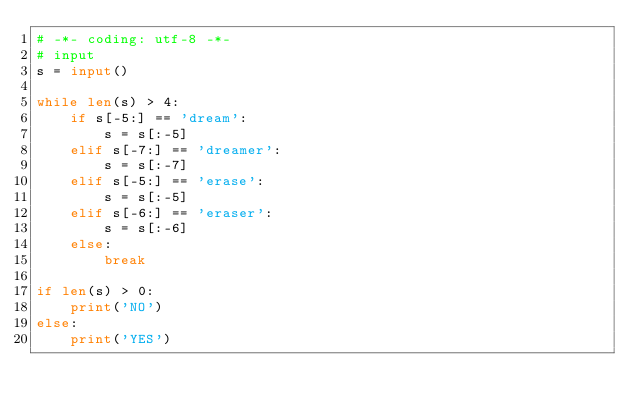Convert code to text. <code><loc_0><loc_0><loc_500><loc_500><_Python_># -*- coding: utf-8 -*-
# input
s = input()

while len(s) > 4:
    if s[-5:] == 'dream':
        s = s[:-5]
    elif s[-7:] == 'dreamer':
        s = s[:-7]
    elif s[-5:] == 'erase':
        s = s[:-5]
    elif s[-6:] == 'eraser':
        s = s[:-6]
    else:
        break

if len(s) > 0:
    print('NO')
else:
    print('YES')
</code> 